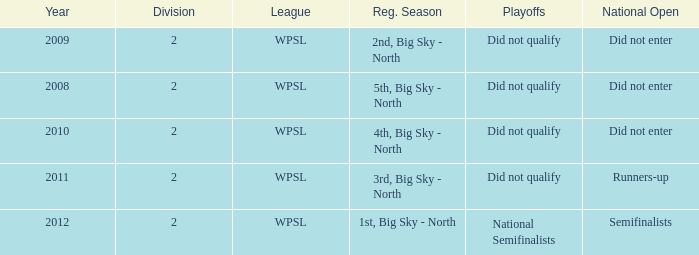What league was involved in 2010? WPSL. 